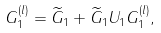Convert formula to latex. <formula><loc_0><loc_0><loc_500><loc_500>G _ { 1 } ^ { ( l ) } = \widetilde { G } _ { 1 } + \widetilde { G } _ { 1 } U _ { 1 } G _ { 1 } ^ { ( l ) } ,</formula> 